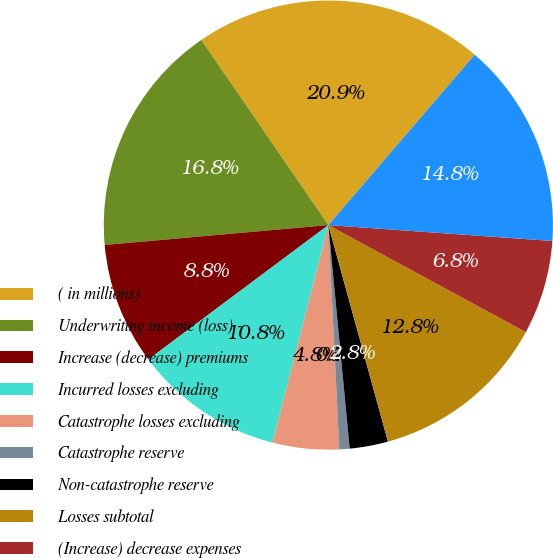Convert chart. <chart><loc_0><loc_0><loc_500><loc_500><pie_chart><fcel>( in millions)<fcel>Underwriting income (loss) -<fcel>Increase (decrease) premiums<fcel>Incurred losses excluding<fcel>Catastrophe losses excluding<fcel>Catastrophe reserve<fcel>Non-catastrophe reserve<fcel>Losses subtotal<fcel>(Increase) decrease expenses<fcel>Underwriting income (loss)<nl><fcel>20.87%<fcel>16.84%<fcel>8.79%<fcel>10.8%<fcel>4.77%<fcel>0.74%<fcel>2.76%<fcel>12.82%<fcel>6.78%<fcel>14.83%<nl></chart> 